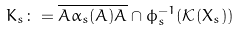Convert formula to latex. <formula><loc_0><loc_0><loc_500><loc_500>K _ { s } \colon = \overline { A \alpha _ { s } ( A ) A } \cap \phi _ { s } ^ { - 1 } ( \mathcal { K } ( X _ { s } ) )</formula> 